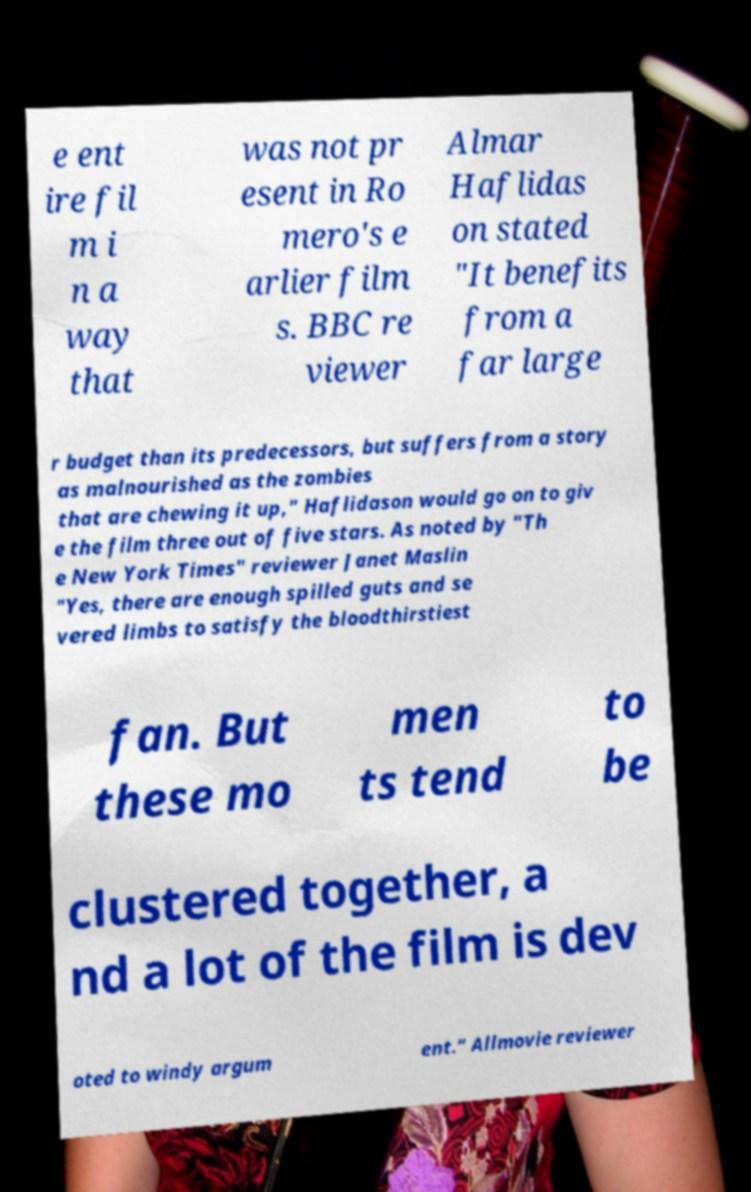What messages or text are displayed in this image? I need them in a readable, typed format. e ent ire fil m i n a way that was not pr esent in Ro mero's e arlier film s. BBC re viewer Almar Haflidas on stated "It benefits from a far large r budget than its predecessors, but suffers from a story as malnourished as the zombies that are chewing it up," Haflidason would go on to giv e the film three out of five stars. As noted by "Th e New York Times" reviewer Janet Maslin "Yes, there are enough spilled guts and se vered limbs to satisfy the bloodthirstiest fan. But these mo men ts tend to be clustered together, a nd a lot of the film is dev oted to windy argum ent." Allmovie reviewer 